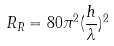<formula> <loc_0><loc_0><loc_500><loc_500>R _ { R } = 8 0 \pi ^ { 2 } ( \frac { h } { \lambda } ) ^ { 2 }</formula> 